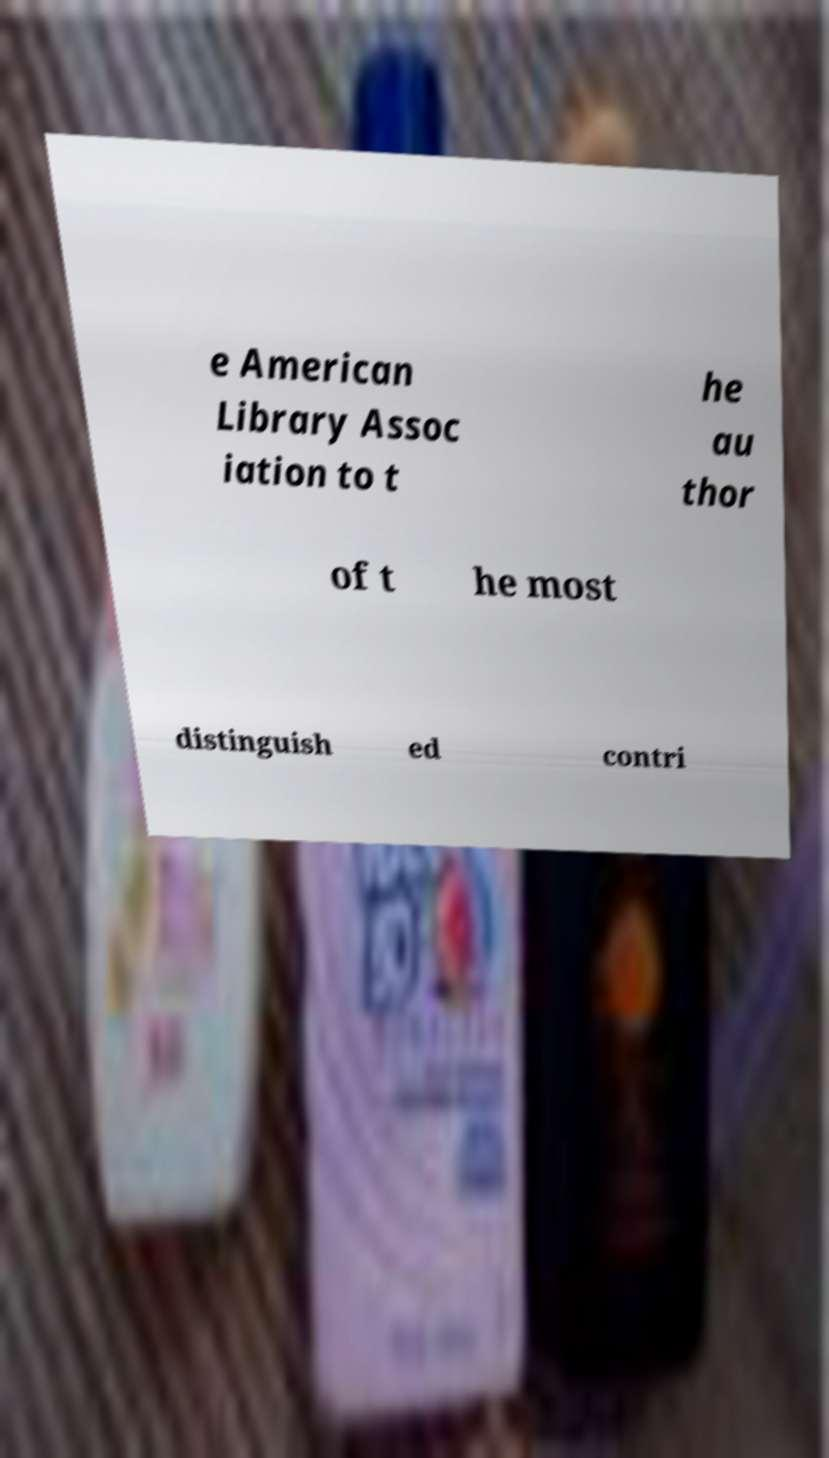There's text embedded in this image that I need extracted. Can you transcribe it verbatim? e American Library Assoc iation to t he au thor of t he most distinguish ed contri 